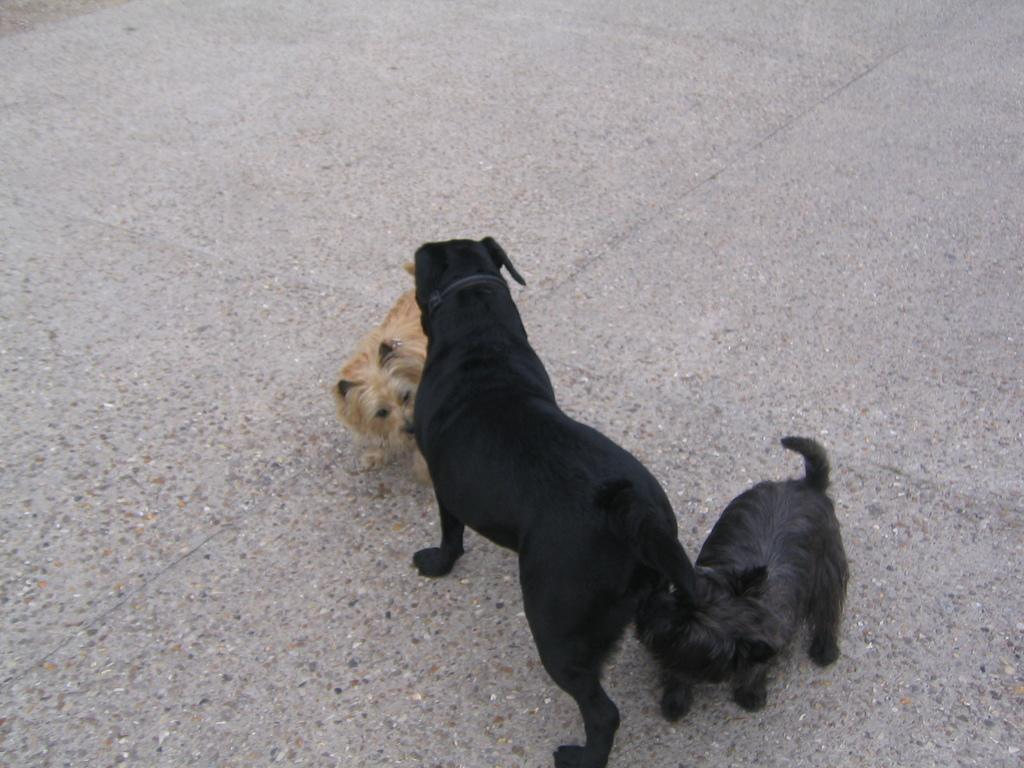How many dogs are present in the image? There are three dogs in the image. What is the position of the dogs in the image? The dogs are standing on the ground. Can you describe the color of the dogs? Two of the dogs are dark in color. What historical event is depicted in the image involving a pot and an animal? There is no historical event, pot, or animal depicted in the image; it features three dogs standing on the ground. 